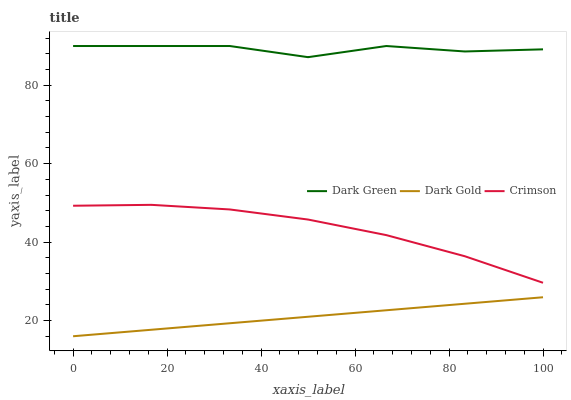Does Dark Gold have the minimum area under the curve?
Answer yes or no. Yes. Does Dark Green have the maximum area under the curve?
Answer yes or no. Yes. Does Dark Green have the minimum area under the curve?
Answer yes or no. No. Does Dark Gold have the maximum area under the curve?
Answer yes or no. No. Is Dark Gold the smoothest?
Answer yes or no. Yes. Is Dark Green the roughest?
Answer yes or no. Yes. Is Dark Green the smoothest?
Answer yes or no. No. Is Dark Gold the roughest?
Answer yes or no. No. Does Dark Gold have the lowest value?
Answer yes or no. Yes. Does Dark Green have the lowest value?
Answer yes or no. No. Does Dark Green have the highest value?
Answer yes or no. Yes. Does Dark Gold have the highest value?
Answer yes or no. No. Is Dark Gold less than Crimson?
Answer yes or no. Yes. Is Dark Green greater than Crimson?
Answer yes or no. Yes. Does Dark Gold intersect Crimson?
Answer yes or no. No. 